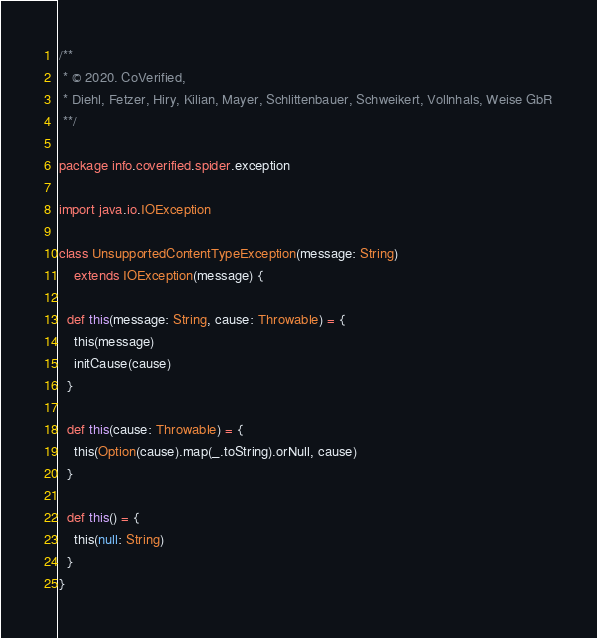Convert code to text. <code><loc_0><loc_0><loc_500><loc_500><_Scala_>/**
 * © 2020. CoVerified,
 * Diehl, Fetzer, Hiry, Kilian, Mayer, Schlittenbauer, Schweikert, Vollnhals, Weise GbR
 **/

package info.coverified.spider.exception

import java.io.IOException

class UnsupportedContentTypeException(message: String)
    extends IOException(message) {

  def this(message: String, cause: Throwable) = {
    this(message)
    initCause(cause)
  }

  def this(cause: Throwable) = {
    this(Option(cause).map(_.toString).orNull, cause)
  }

  def this() = {
    this(null: String)
  }
}
</code> 